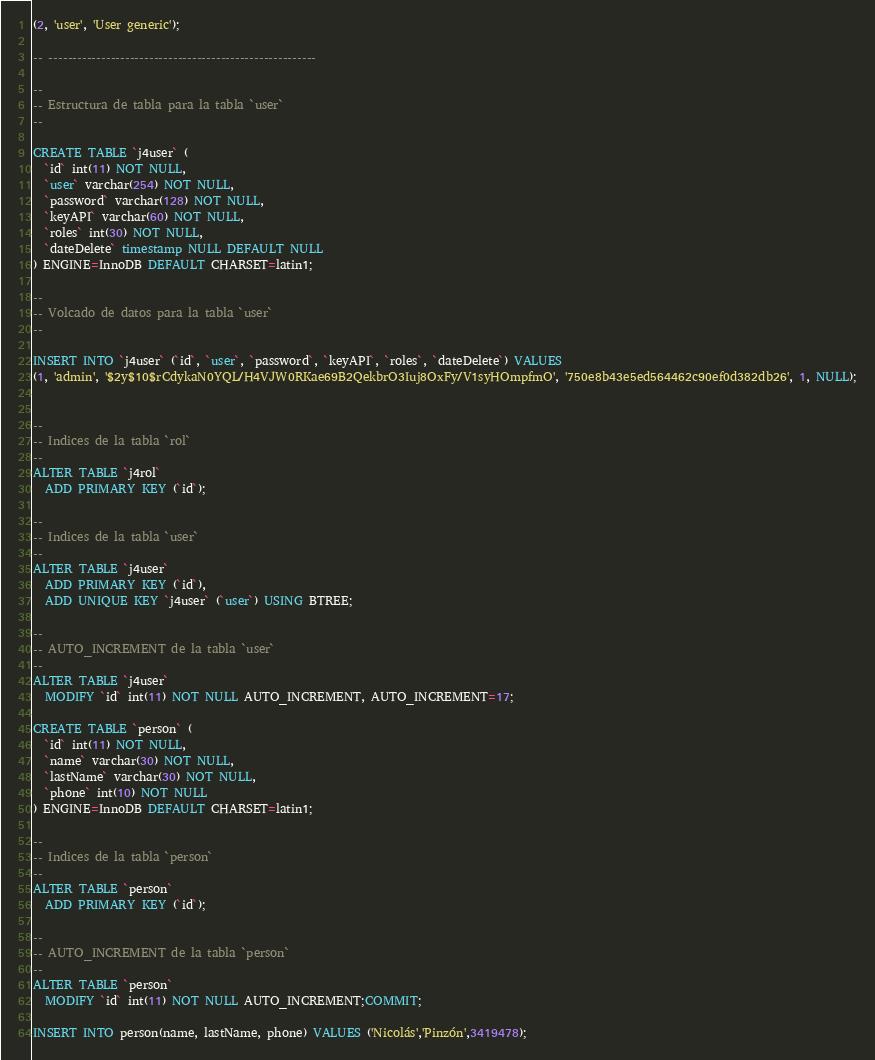<code> <loc_0><loc_0><loc_500><loc_500><_SQL_>(2, 'user', 'User generic');

-- --------------------------------------------------------

--
-- Estructura de tabla para la tabla `user`
--

CREATE TABLE `j4user` (
  `id` int(11) NOT NULL,
  `user` varchar(254) NOT NULL,
  `password` varchar(128) NOT NULL,
  `keyAPI` varchar(60) NOT NULL,
  `roles` int(30) NOT NULL,
  `dateDelete` timestamp NULL DEFAULT NULL
) ENGINE=InnoDB DEFAULT CHARSET=latin1;

--
-- Volcado de datos para la tabla `user`
--

INSERT INTO `j4user` (`id`, `user`, `password`, `keyAPI`, `roles`, `dateDelete`) VALUES
(1, 'admin', '$2y$10$rCdykaN0YQL/H4VJW0RKae69B2QekbrO3Iuj8OxFy/V1syHOmpfmO', '750e8b43e5ed564462c90ef0d382db26', 1, NULL);


--
-- Indices de la tabla `rol`
--
ALTER TABLE `j4rol`
  ADD PRIMARY KEY (`id`);

--
-- Indices de la tabla `user`
--
ALTER TABLE `j4user`
  ADD PRIMARY KEY (`id`),
  ADD UNIQUE KEY `j4user` (`user`) USING BTREE;

--
-- AUTO_INCREMENT de la tabla `user`
--
ALTER TABLE `j4user`
  MODIFY `id` int(11) NOT NULL AUTO_INCREMENT, AUTO_INCREMENT=17;
  
CREATE TABLE `person` (
  `id` int(11) NOT NULL,
  `name` varchar(30) NOT NULL,
  `lastName` varchar(30) NOT NULL,
  `phone` int(10) NOT NULL
) ENGINE=InnoDB DEFAULT CHARSET=latin1;

--
-- Indices de la tabla `person`
--
ALTER TABLE `person`
  ADD PRIMARY KEY (`id`);

--
-- AUTO_INCREMENT de la tabla `person`
--
ALTER TABLE `person`
  MODIFY `id` int(11) NOT NULL AUTO_INCREMENT;COMMIT;

INSERT INTO person(name, lastName, phone) VALUES ('Nicolás','Pinzón',3419478);
</code> 